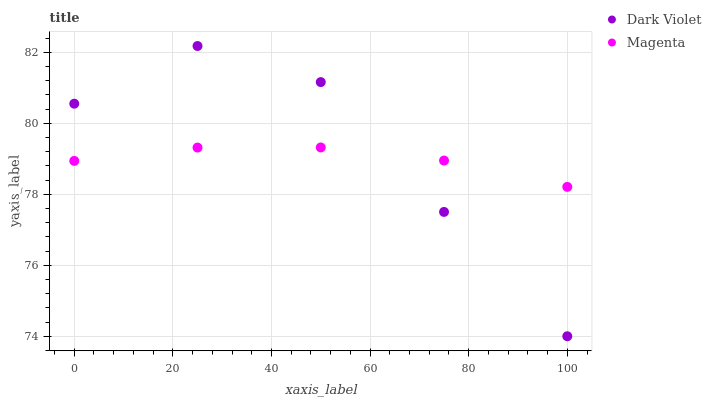Does Magenta have the minimum area under the curve?
Answer yes or no. Yes. Does Dark Violet have the maximum area under the curve?
Answer yes or no. Yes. Does Dark Violet have the minimum area under the curve?
Answer yes or no. No. Is Magenta the smoothest?
Answer yes or no. Yes. Is Dark Violet the roughest?
Answer yes or no. Yes. Is Dark Violet the smoothest?
Answer yes or no. No. Does Dark Violet have the lowest value?
Answer yes or no. Yes. Does Dark Violet have the highest value?
Answer yes or no. Yes. Does Dark Violet intersect Magenta?
Answer yes or no. Yes. Is Dark Violet less than Magenta?
Answer yes or no. No. Is Dark Violet greater than Magenta?
Answer yes or no. No. 